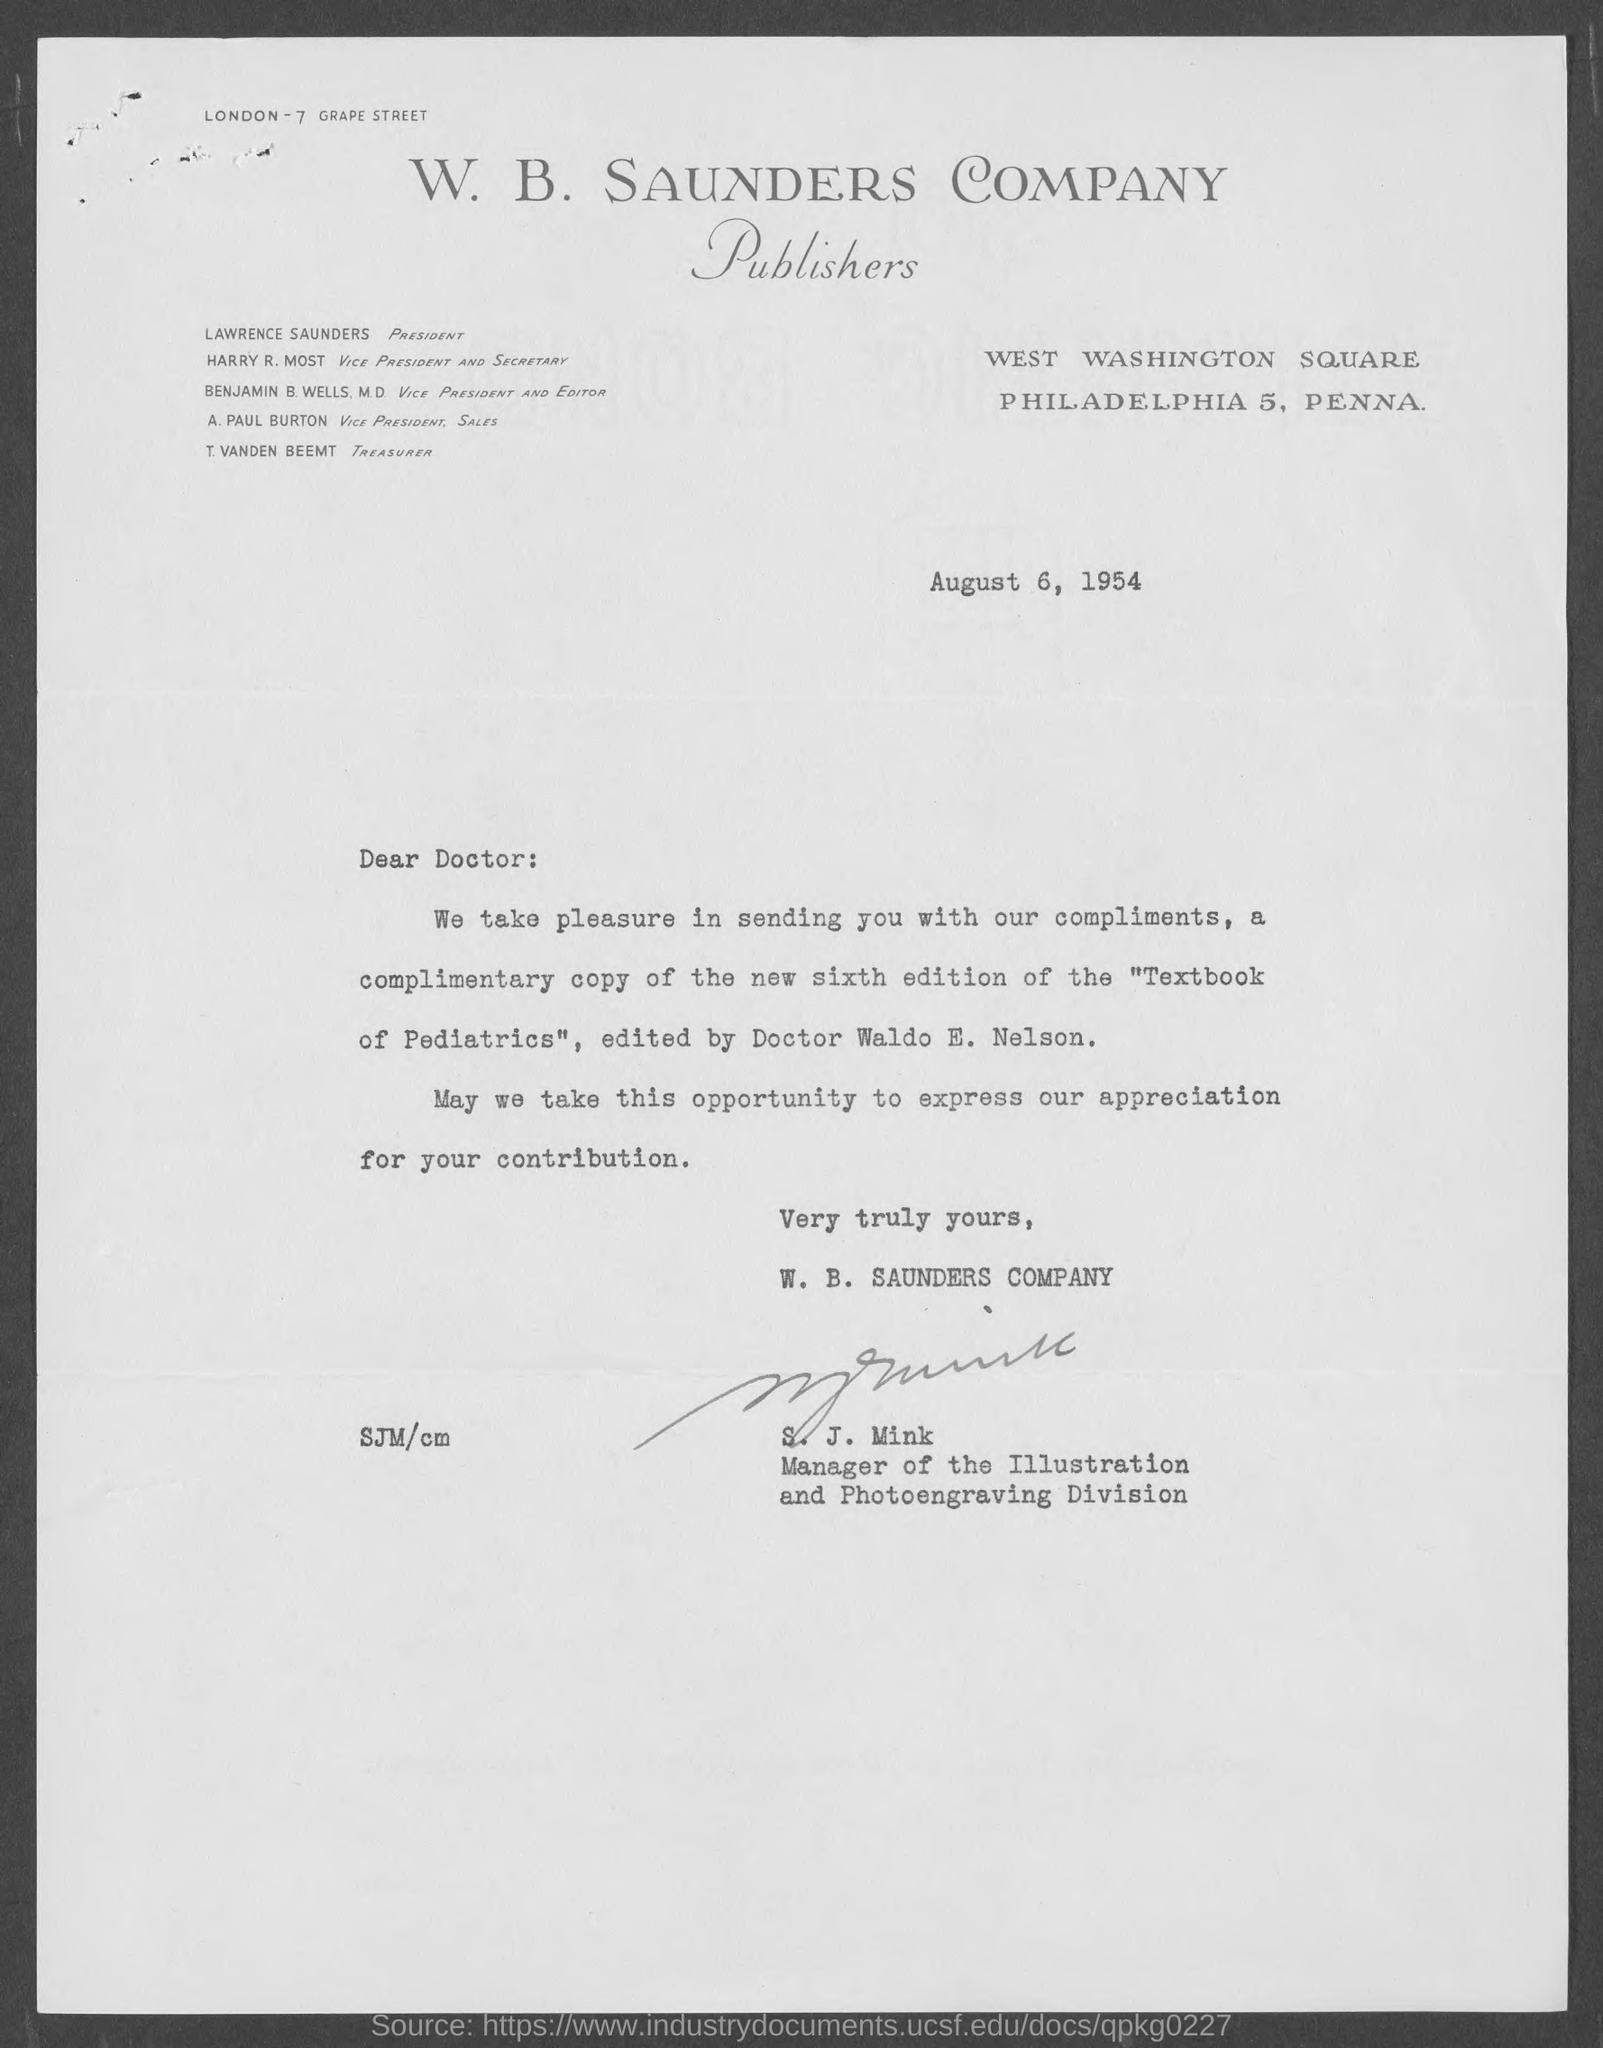Who is the President?
Provide a succinct answer. LAWRENCE SAUNDERS. What is the date on the document?
Offer a terse response. August 6, 1954. Who is the Vice President and Editor?
Ensure brevity in your answer.  BENJAMIN B. WELLS, M.D. Who is the Vice President and Secretary?
Offer a terse response. HARRY R. MOST. Who is the Vice President, Sales?
Ensure brevity in your answer.  A. Paul Burton. Who is the Treasurer?
Your response must be concise. T. VANDEN BEEMT. 